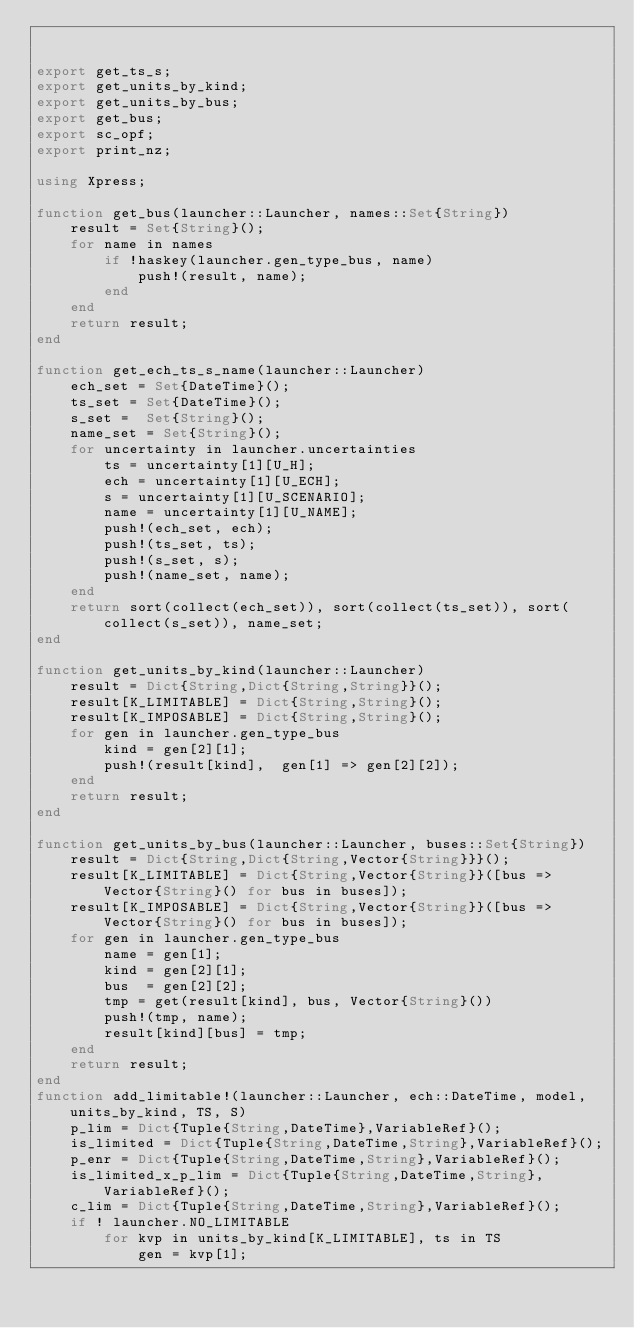<code> <loc_0><loc_0><loc_500><loc_500><_Julia_>

export get_ts_s;
export get_units_by_kind;
export get_units_by_bus;
export get_bus;
export sc_opf;
export print_nz;

using Xpress;

function get_bus(launcher::Launcher, names::Set{String})
    result = Set{String}();
    for name in names
        if !haskey(launcher.gen_type_bus, name)
            push!(result, name);
        end
    end
    return result;
end

function get_ech_ts_s_name(launcher::Launcher)
    ech_set = Set{DateTime}();
    ts_set = Set{DateTime}();
    s_set =  Set{String}();
    name_set = Set{String}();
    for uncertainty in launcher.uncertainties
        ts = uncertainty[1][U_H];
        ech = uncertainty[1][U_ECH];
        s = uncertainty[1][U_SCENARIO];
        name = uncertainty[1][U_NAME];
        push!(ech_set, ech);
        push!(ts_set, ts);
        push!(s_set, s);
        push!(name_set, name);
    end
    return sort(collect(ech_set)), sort(collect(ts_set)), sort(collect(s_set)), name_set;
end

function get_units_by_kind(launcher::Launcher)
    result = Dict{String,Dict{String,String}}();
    result[K_LIMITABLE] = Dict{String,String}();
    result[K_IMPOSABLE] = Dict{String,String}();
    for gen in launcher.gen_type_bus
        kind = gen[2][1];
        push!(result[kind],  gen[1] => gen[2][2]);
    end 
    return result;
end

function get_units_by_bus(launcher::Launcher, buses::Set{String})
    result = Dict{String,Dict{String,Vector{String}}}();
    result[K_LIMITABLE] = Dict{String,Vector{String}}([bus => Vector{String}() for bus in buses]);
    result[K_IMPOSABLE] = Dict{String,Vector{String}}([bus => Vector{String}() for bus in buses]);
    for gen in launcher.gen_type_bus
        name = gen[1];
        kind = gen[2][1];
        bus  = gen[2][2];
        tmp = get(result[kind], bus, Vector{String}())
        push!(tmp, name);
        result[kind][bus] = tmp;
    end 
    return result;
end
function add_limitable!(launcher::Launcher, ech::DateTime, model, units_by_kind, TS, S)
    p_lim = Dict{Tuple{String,DateTime},VariableRef}();    
    is_limited = Dict{Tuple{String,DateTime,String},VariableRef}();
    p_enr = Dict{Tuple{String,DateTime,String},VariableRef}();
    is_limited_x_p_lim = Dict{Tuple{String,DateTime,String},VariableRef}();
    c_lim = Dict{Tuple{String,DateTime,String},VariableRef}();
    if ! launcher.NO_LIMITABLE
        for kvp in units_by_kind[K_LIMITABLE], ts in TS
            gen = kvp[1];</code> 